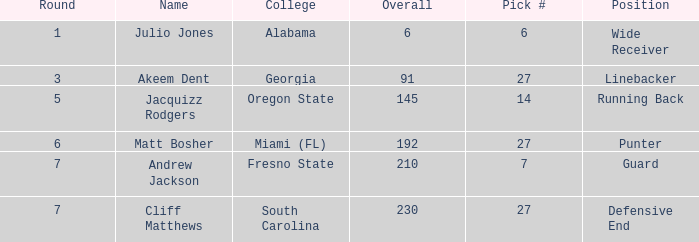Which overall's pick number was 14? 145.0. 